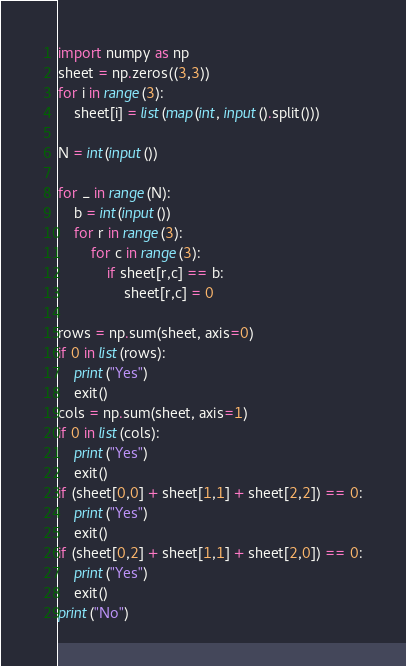<code> <loc_0><loc_0><loc_500><loc_500><_Python_>import numpy as np
sheet = np.zeros((3,3))
for i in range(3):
    sheet[i] = list(map(int, input().split()))

N = int(input())

for _ in range(N):
    b = int(input())
    for r in range(3):
        for c in range(3):
            if sheet[r,c] == b:
                sheet[r,c] = 0

rows = np.sum(sheet, axis=0)
if 0 in list(rows):
    print("Yes")
    exit()
cols = np.sum(sheet, axis=1)
if 0 in list(cols):
    print("Yes")
    exit()
if (sheet[0,0] + sheet[1,1] + sheet[2,2]) == 0:
    print("Yes")
    exit()
if (sheet[0,2] + sheet[1,1] + sheet[2,0]) == 0:
    print("Yes")
    exit()
print("No")
</code> 